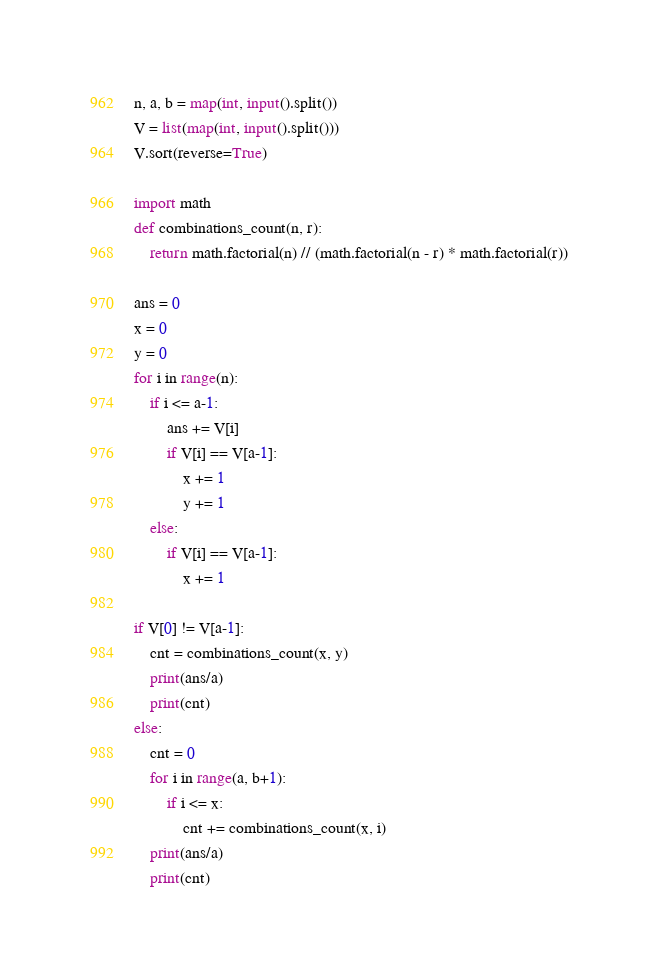Convert code to text. <code><loc_0><loc_0><loc_500><loc_500><_Python_>n, a, b = map(int, input().split())
V = list(map(int, input().split()))
V.sort(reverse=True)

import math
def combinations_count(n, r):
    return math.factorial(n) // (math.factorial(n - r) * math.factorial(r))

ans = 0
x = 0
y = 0
for i in range(n):
    if i <= a-1:
        ans += V[i]
        if V[i] == V[a-1]:
            x += 1
            y += 1
    else:
        if V[i] == V[a-1]:
            x += 1

if V[0] != V[a-1]:
    cnt = combinations_count(x, y)
    print(ans/a)
    print(cnt)
else:
    cnt = 0
    for i in range(a, b+1):
        if i <= x:
            cnt += combinations_count(x, i)
    print(ans/a)
    print(cnt)</code> 